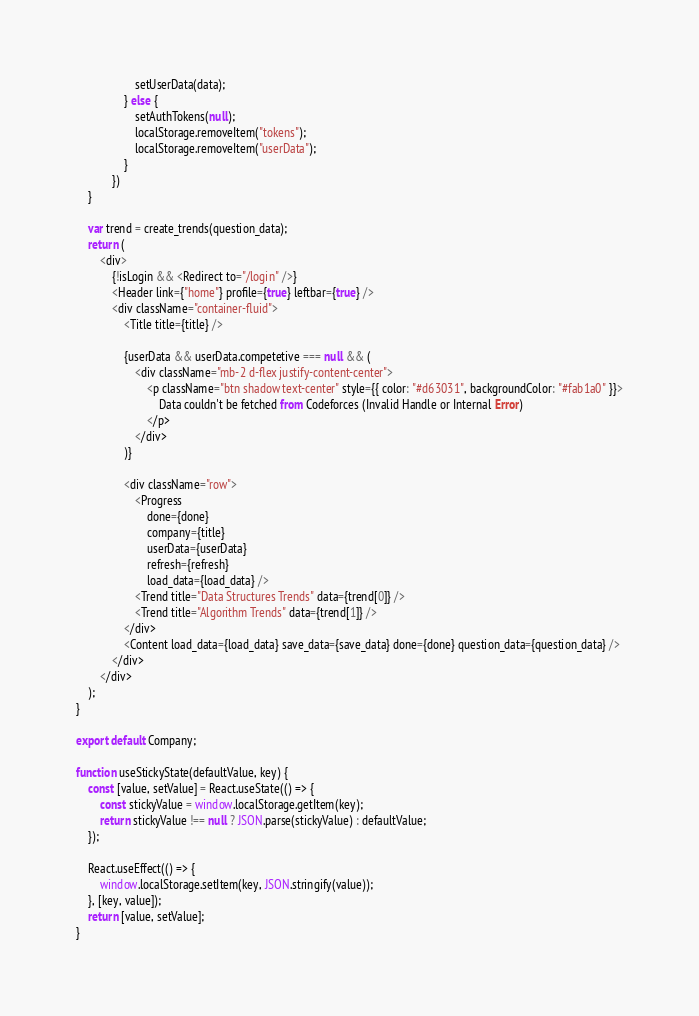Convert code to text. <code><loc_0><loc_0><loc_500><loc_500><_JavaScript_>                    setUserData(data);
                } else {
                    setAuthTokens(null);
                    localStorage.removeItem("tokens");
                    localStorage.removeItem("userData");
                }
            })
    }

    var trend = create_trends(question_data);
    return (
        <div>
            {!isLogin && <Redirect to="/login" />}
            <Header link={"home"} profile={true} leftbar={true} />
            <div className="container-fluid">
                <Title title={title} />

                {userData && userData.competetive === null && (
                    <div className="mb-2 d-flex justify-content-center">
                        <p className="btn shadow text-center" style={{ color: "#d63031", backgroundColor: "#fab1a0" }}>
                            Data couldn't be fetched from Codeforces (Invalid Handle or Internal Error)
                        </p>
                    </div>
                )}
                
                <div className="row">
                    <Progress
                        done={done}
                        company={title}
                        userData={userData}
                        refresh={refresh}
                        load_data={load_data} />
                    <Trend title="Data Structures Trends" data={trend[0]} />
                    <Trend title="Algorithm Trends" data={trend[1]} />
                </div>
                <Content load_data={load_data} save_data={save_data} done={done} question_data={question_data} />
            </div>
        </div>
    );
}

export default Company;

function useStickyState(defaultValue, key) {
    const [value, setValue] = React.useState(() => {
        const stickyValue = window.localStorage.getItem(key);
        return stickyValue !== null ? JSON.parse(stickyValue) : defaultValue;
    });

    React.useEffect(() => {
        window.localStorage.setItem(key, JSON.stringify(value));
    }, [key, value]);
    return [value, setValue];
}</code> 